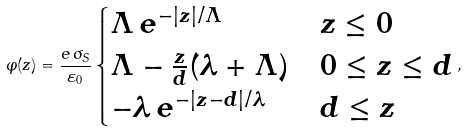Convert formula to latex. <formula><loc_0><loc_0><loc_500><loc_500>\varphi ( z ) = \frac { e \, \sigma _ { S } } { \varepsilon _ { 0 } } \begin{cases} \Lambda \, e ^ { - | z | / \Lambda } & z \leq 0 \\ \Lambda - \frac { z } { d } ( \lambda + \Lambda ) & 0 \leq z \leq d \\ - \lambda \, e ^ { - | z - d | / \lambda } & d \leq z \end{cases} ,</formula> 